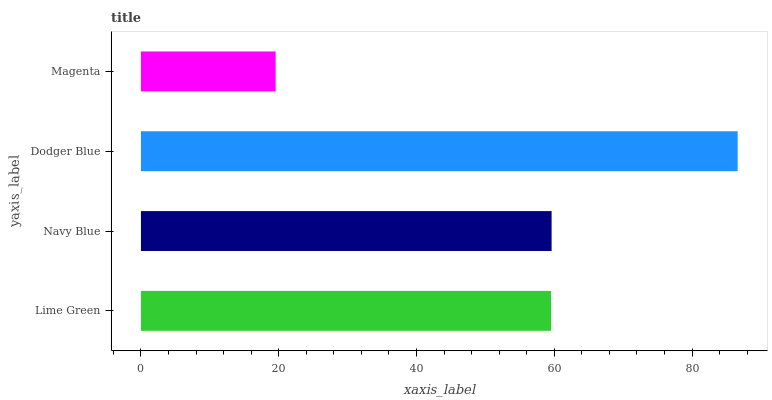Is Magenta the minimum?
Answer yes or no. Yes. Is Dodger Blue the maximum?
Answer yes or no. Yes. Is Navy Blue the minimum?
Answer yes or no. No. Is Navy Blue the maximum?
Answer yes or no. No. Is Navy Blue greater than Lime Green?
Answer yes or no. Yes. Is Lime Green less than Navy Blue?
Answer yes or no. Yes. Is Lime Green greater than Navy Blue?
Answer yes or no. No. Is Navy Blue less than Lime Green?
Answer yes or no. No. Is Navy Blue the high median?
Answer yes or no. Yes. Is Lime Green the low median?
Answer yes or no. Yes. Is Lime Green the high median?
Answer yes or no. No. Is Dodger Blue the low median?
Answer yes or no. No. 